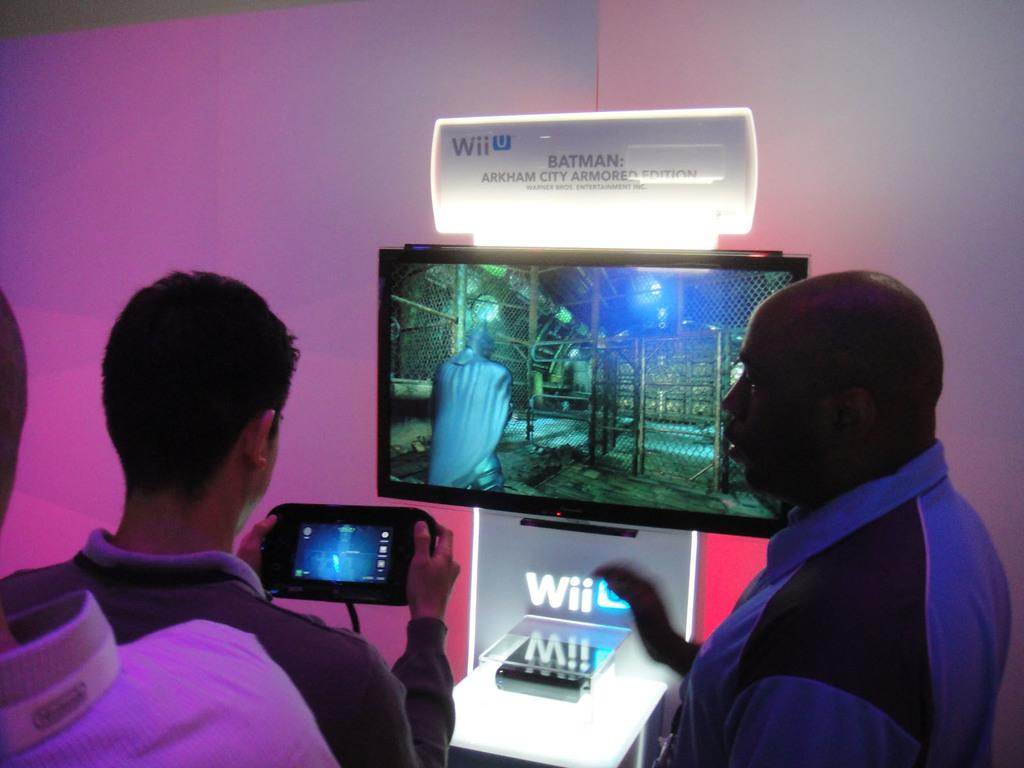<image>
Summarize the visual content of the image. A man plays Batman: Arkham City Armored Edition on a Wii display. 